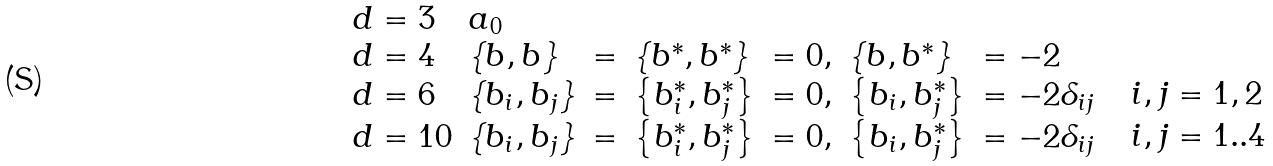Convert formula to latex. <formula><loc_0><loc_0><loc_500><loc_500>\begin{array} { l l l l l l l l } { d = 3 } & { { a _ { 0 } } } & { { \begin{array} { l } \end{array} } } \\ { d = 4 } & { { \left \{ b , b \right \} } } & { = } & { { \left \{ b ^ { * } , b ^ { * } \right \} } } & { = 0 , } & { { \left \{ b , b ^ { * } \right \} } } & { = - 2 } & { { \begin{array} { l } \end{array} } } \\ { d = 6 } & { { \left \{ b _ { i } , b _ { j } \right \} } } & { = } & { { \left \{ b _ { i } ^ { * } , b _ { j } ^ { * } \right \} } } & { = 0 , } & { { \left \{ b _ { i } , b _ { j } ^ { * } \right \} } } & { { = - 2 \delta _ { i j } } } & { { \begin{array} { l } { \ i , j = 1 , 2 } \end{array} } } \\ { d = 1 0 } & { { \left \{ b _ { i } , b _ { j } \right \} } } & { = } & { { \left \{ b _ { i } ^ { * } , b _ { j } ^ { * } \right \} } } & { = 0 , } & { { \left \{ b _ { i } , b _ { j } ^ { * } \right \} } } & { { = - 2 \delta _ { i j } } } & { { \begin{array} { l } { \ i , j = 1 . . 4 } \end{array} } } \end{array}</formula> 